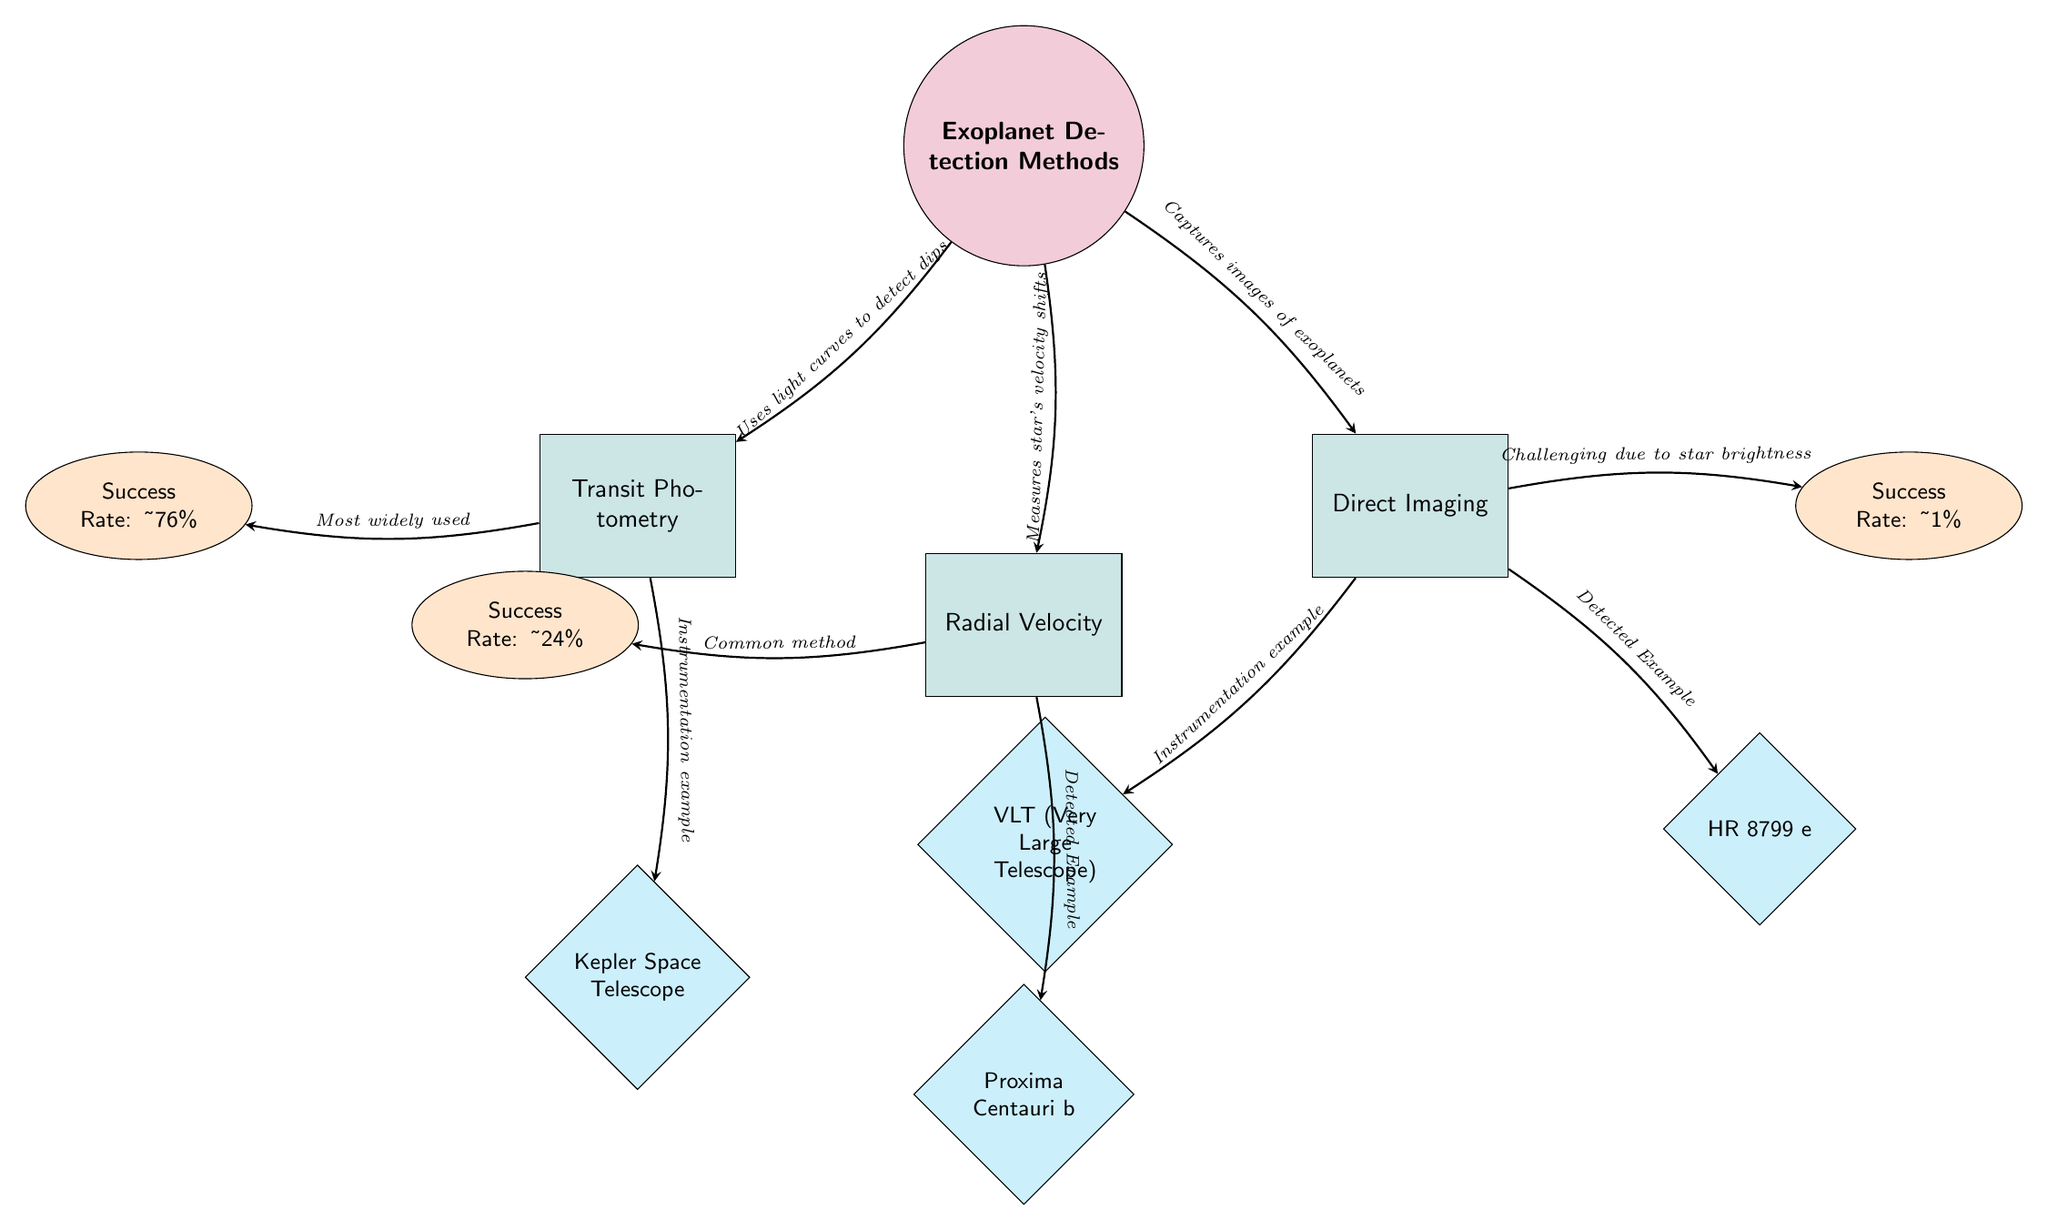What is the success rate of Transit Photometry? The diagram states that Transit Photometry has a success rate of approximately 76%, as indicated by the success rate node connected to the Transit Photometry method node.
Answer: 76% Which detection method has the lowest success rate? By examining the success rate nodes, Direct Imaging is shown to have the lowest success rate of approximately 1%, which is represented in the diagram.
Answer: 1% What does Radial Velocity measure? The diagram notes that the Radial Velocity method measures star's velocity shifts, linking the main node to the Radial Velocity method node.
Answer: Star's velocity shifts Which example is associated with the Direct Imaging method? The diagram lists two examples for the Direct Imaging method, specifically the Very Large Telescope and HR 8799 e. The question refers to any of these examples, leading to a valid answer.
Answer: VLT (Very Large Telescope) How is Transit Photometry described in the diagram? According to the diagram, Transit Photometry is described as using light curves to detect dips, which is shown in the arrow connecting the main node to the Transit Photometry method node.
Answer: Uses light curves to detect dips What can you infer about the popularity of Transit Photometry compared to the other methods? The diagram indicates that Transit Photometry is described as the most widely used method, which suggests it is more popular compared to Radial Velocity and Direct Imaging.
Answer: Most widely used Which exoplanet is an example of the Radial Velocity method? The diagram specifies that Proxima Centauri b is an example linked to the Radial Velocity method node, detailing this connection clearly within the structure.
Answer: Proxima Centauri b How do Direct Imaging methods obtain data? The diagram illustrates that Direct Imaging captures images of exoplanets, denoting this clearly in the connection from the main node to the Direct Imaging method node.
Answer: Captures images of exoplanets What is the challenge of Direct Imaging mentioned in the diagram? The diagram states the challenge of Direct Imaging is due to star brightness, which reveals why obtaining valid images is difficult for this method, noted by the description near the success rate node.
Answer: Challenging due to star brightness 